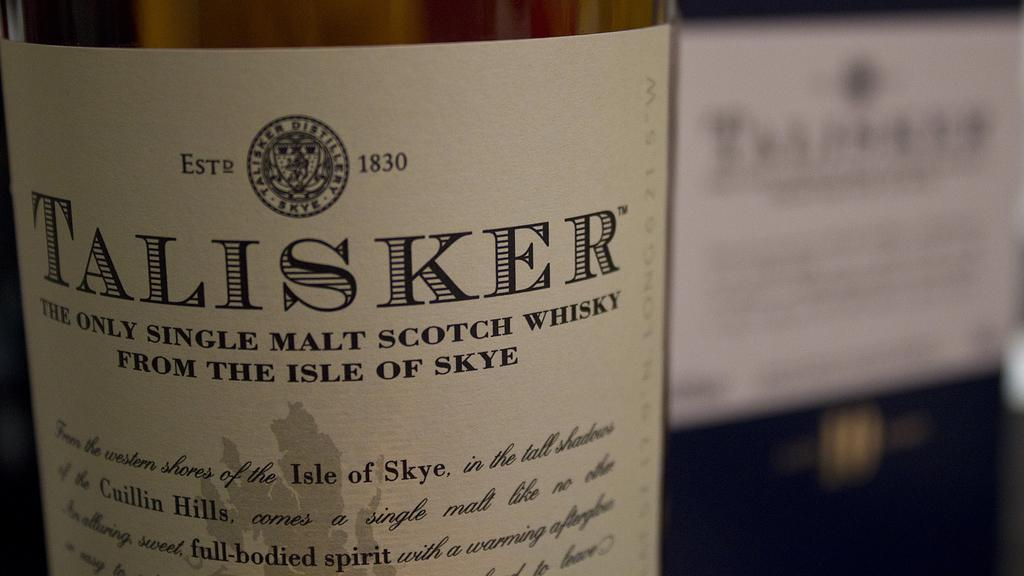<image>
Write a terse but informative summary of the picture. Label of a bottle of whiskey from the year 1830. 